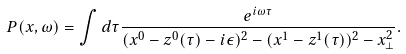<formula> <loc_0><loc_0><loc_500><loc_500>P ( x , \omega ) = \int d \tau \frac { e ^ { i \omega \tau } } { ( x ^ { 0 } - z ^ { 0 } ( \tau ) - i \epsilon ) ^ { 2 } - ( x ^ { 1 } - z ^ { 1 } ( \tau ) ) ^ { 2 } - x _ { \perp } ^ { 2 } } .</formula> 